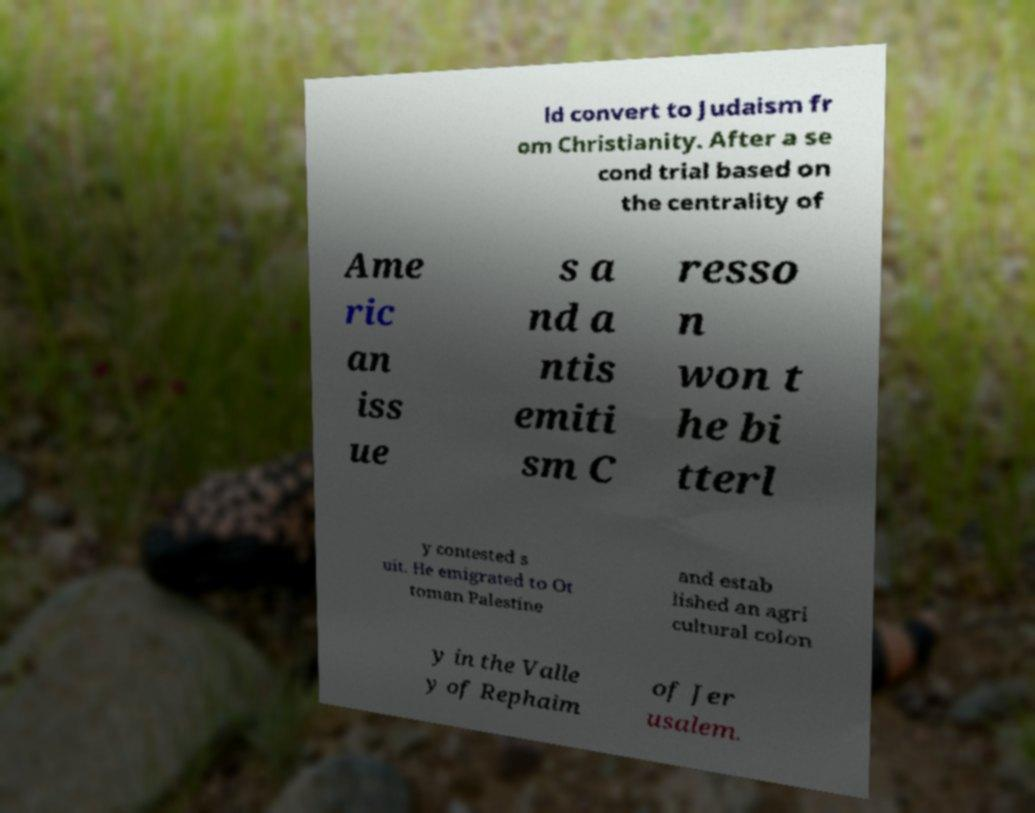Could you extract and type out the text from this image? ld convert to Judaism fr om Christianity. After a se cond trial based on the centrality of Ame ric an iss ue s a nd a ntis emiti sm C resso n won t he bi tterl y contested s uit. He emigrated to Ot toman Palestine and estab lished an agri cultural colon y in the Valle y of Rephaim of Jer usalem. 